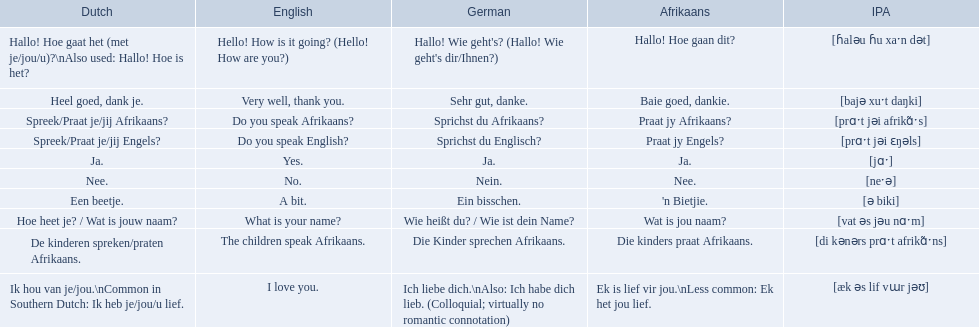What are all of the afrikaans phrases in the list? Hallo! Hoe gaan dit?, Baie goed, dankie., Praat jy Afrikaans?, Praat jy Engels?, Ja., Nee., 'n Bietjie., Wat is jou naam?, Die kinders praat Afrikaans., Ek is lief vir jou.\nLess common: Ek het jou lief. What is the english translation of each phrase? Hello! How is it going? (Hello! How are you?), Very well, thank you., Do you speak Afrikaans?, Do you speak English?, Yes., No., A bit., What is your name?, The children speak Afrikaans., I love you. And which afrikaans phrase translated to do you speak afrikaans? Praat jy Afrikaans?. 